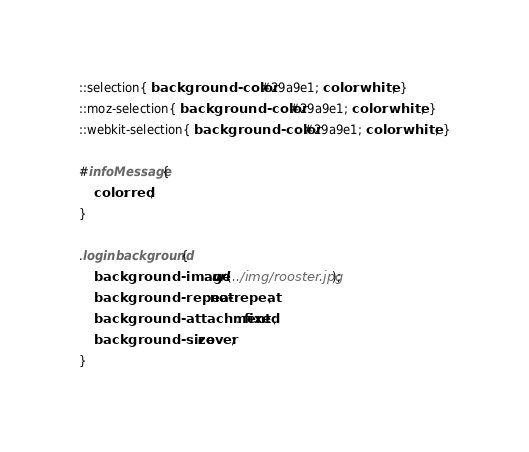<code> <loc_0><loc_0><loc_500><loc_500><_CSS_>::selection{ background-color: #29a9e1; color: white; }
::moz-selection{ background-color: #29a9e1; color: white; }
::webkit-selection{ background-color: #29a9e1; color: white; }

#infoMessage{
	color: red;
}

.loginbackground{    
    background-image: url(../img/rooster.jpg);
    background-repeat:no-repeat;
    background-attachment: fixed;
    background-size: cover;
}</code> 